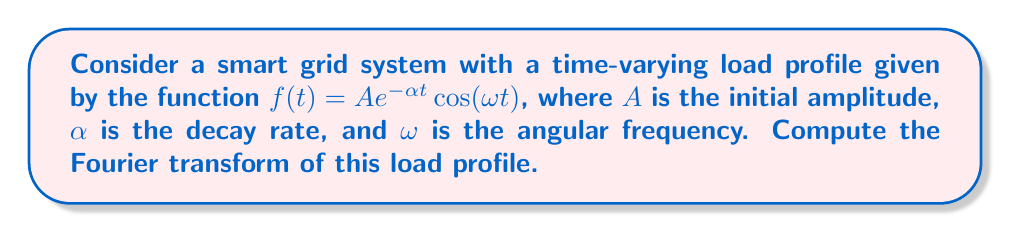Can you answer this question? To compute the Fourier transform of the given time-varying load profile, we'll follow these steps:

1) The Fourier transform is defined as:
   $$F(\nu) = \int_{-\infty}^{\infty} f(t) e^{-i2\pi\nu t} dt$$

2) Substituting our function $f(t) = A e^{-\alpha t} \cos(\omega t)$ into the Fourier transform equation:
   $$F(\nu) = A \int_{-\infty}^{\infty} e^{-\alpha t} \cos(\omega t) e^{-i2\pi\nu t} dt$$

3) Using Euler's formula, we can write $\cos(\omega t)$ as:
   $$\cos(\omega t) = \frac{1}{2}(e^{i\omega t} + e^{-i\omega t})$$

4) Substituting this into our integral:
   $$F(\nu) = \frac{A}{2} \int_{-\infty}^{\infty} e^{-\alpha t} (e^{i\omega t} + e^{-i\omega t}) e^{-i2\pi\nu t} dt$$

5) Distributing the $e^{-i2\pi\nu t}$ term:
   $$F(\nu) = \frac{A}{2} \int_{-\infty}^{\infty} e^{-\alpha t} (e^{i(\omega-2\pi\nu) t} + e^{-i(\omega+2\pi\nu) t}) dt$$

6) This can be split into two integrals:
   $$F(\nu) = \frac{A}{2} \int_{-\infty}^{\infty} e^{-(\alpha+i(\omega-2\pi\nu)) t} dt + \frac{A}{2} \int_{-\infty}^{\infty} e^{-(\alpha+i(\omega+2\pi\nu)) t} dt$$

7) Both integrals are of the form $\int_{-\infty}^{\infty} e^{-at} dt = \frac{2}{a}$ for $Re(a) > 0$. Here, $a = \alpha \pm i(\omega \mp 2\pi\nu)$.

8) Evaluating the integrals:
   $$F(\nu) = \frac{A}{2} \cdot \frac{2}{\alpha+i(\omega-2\pi\nu)} + \frac{A}{2} \cdot \frac{2}{\alpha+i(\omega+2\pi\nu)}$$

9) Simplifying:
   $$F(\nu) = \frac{A}{\alpha+i(\omega-2\pi\nu)} + \frac{A}{\alpha+i(\omega+2\pi\nu)}$$

10) This can be written as a single fraction:
    $$F(\nu) = \frac{A(\alpha-i(\omega-2\pi\nu)) + A(\alpha-i(\omega+2\pi\nu))}{(\alpha+i(\omega-2\pi\nu))(\alpha+i(\omega+2\pi\nu))}$$

11) Simplifying the numerator:
    $$F(\nu) = \frac{2A\alpha}{(\alpha+i(\omega-2\pi\nu))(\alpha+i(\omega+2\pi\nu))}$$

12) The denominator can be expanded as:
    $$(\alpha+i(\omega-2\pi\nu))(\alpha+i(\omega+2\pi\nu)) = \alpha^2 + (\omega^2 - (2\pi\nu)^2) + 2i\alpha\omega$$

Therefore, the final form of the Fourier transform is:
$$F(\nu) = \frac{2A\alpha}{\alpha^2 + (\omega^2 - (2\pi\nu)^2) + 2i\alpha\omega}$$
Answer: $$F(\nu) = \frac{2A\alpha}{\alpha^2 + (\omega^2 - (2\pi\nu)^2) + 2i\alpha\omega}$$ 